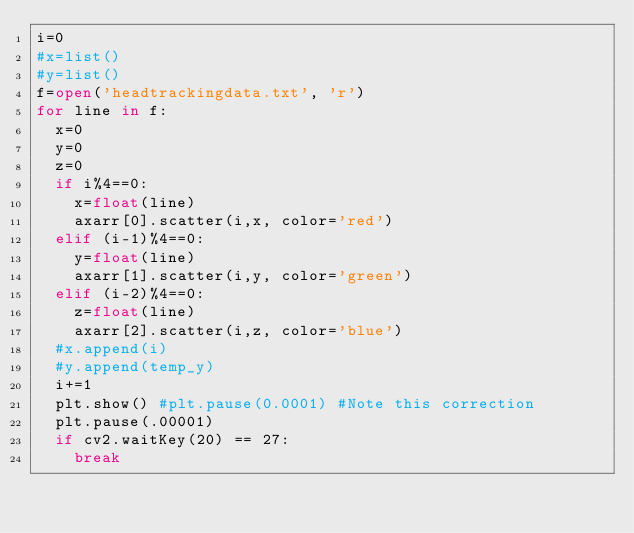<code> <loc_0><loc_0><loc_500><loc_500><_Python_>i=0
#x=list()
#y=list()
f=open('headtrackingdata.txt', 'r')
for line in f:
	x=0
	y=0
	z=0
	if i%4==0:
		x=float(line)
		axarr[0].scatter(i,x, color='red')
	elif (i-1)%4==0:
		y=float(line)
		axarr[1].scatter(i,y, color='green')
	elif (i-2)%4==0:
		z=float(line)
		axarr[2].scatter(i,z, color='blue')
	#x.append(i)
	#y.append(temp_y)
	i+=1
	plt.show() #plt.pause(0.0001) #Note this correction
	plt.pause(.00001)
	if cv2.waitKey(20) == 27:
		break</code> 